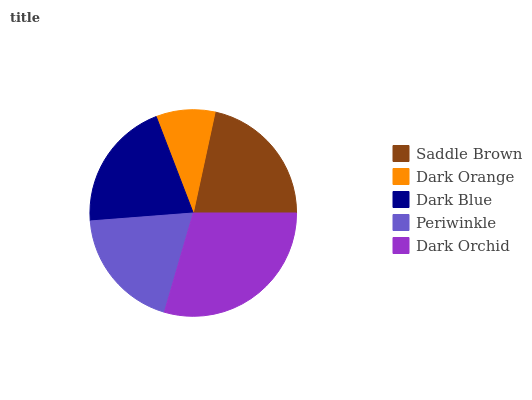Is Dark Orange the minimum?
Answer yes or no. Yes. Is Dark Orchid the maximum?
Answer yes or no. Yes. Is Dark Blue the minimum?
Answer yes or no. No. Is Dark Blue the maximum?
Answer yes or no. No. Is Dark Blue greater than Dark Orange?
Answer yes or no. Yes. Is Dark Orange less than Dark Blue?
Answer yes or no. Yes. Is Dark Orange greater than Dark Blue?
Answer yes or no. No. Is Dark Blue less than Dark Orange?
Answer yes or no. No. Is Dark Blue the high median?
Answer yes or no. Yes. Is Dark Blue the low median?
Answer yes or no. Yes. Is Periwinkle the high median?
Answer yes or no. No. Is Saddle Brown the low median?
Answer yes or no. No. 